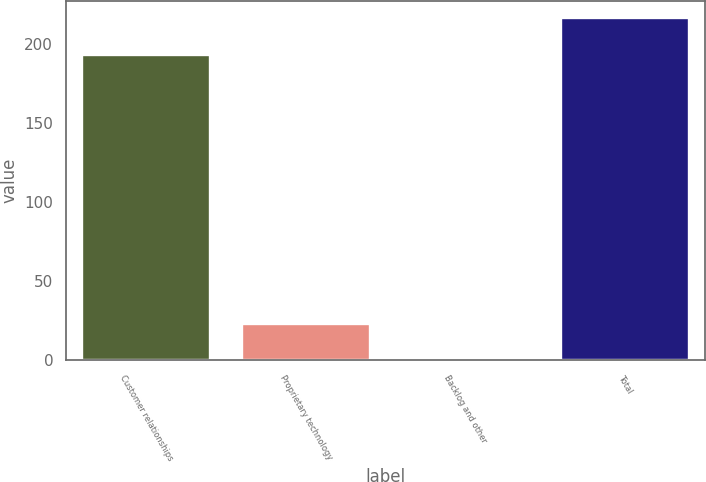Convert chart. <chart><loc_0><loc_0><loc_500><loc_500><bar_chart><fcel>Customer relationships<fcel>Proprietary technology<fcel>Backlog and other<fcel>Total<nl><fcel>193<fcel>22.9<fcel>0.5<fcel>216.4<nl></chart> 